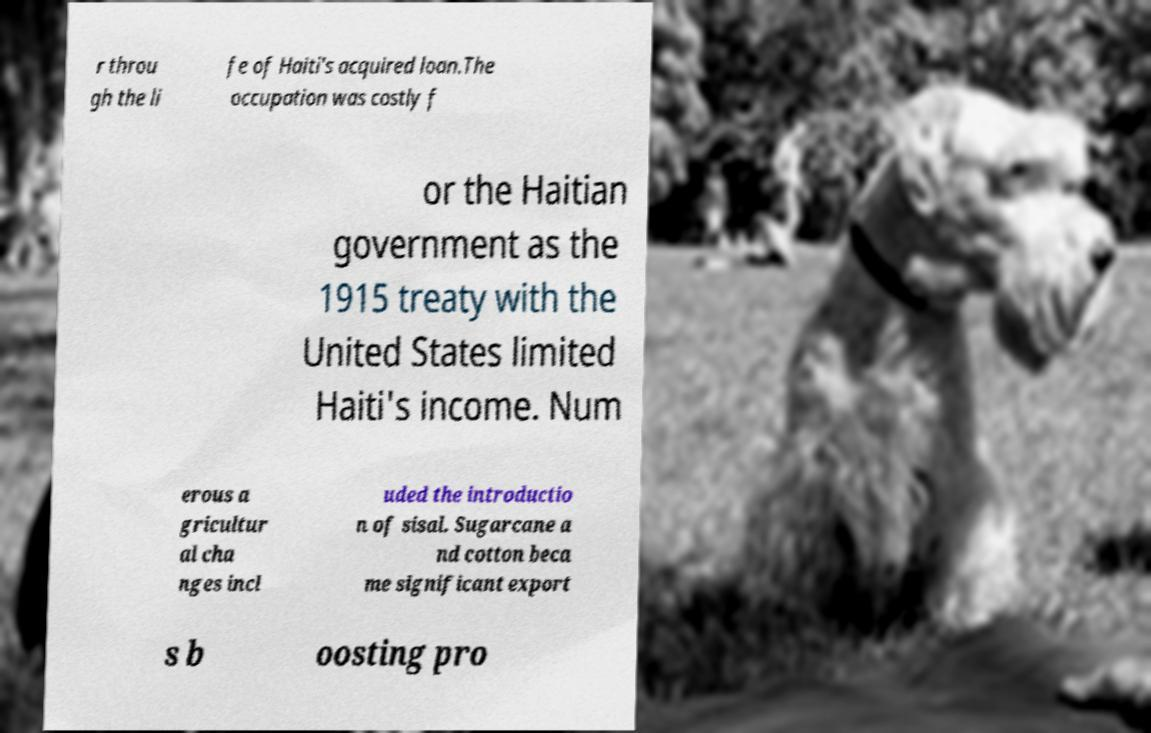What messages or text are displayed in this image? I need them in a readable, typed format. r throu gh the li fe of Haiti's acquired loan.The occupation was costly f or the Haitian government as the 1915 treaty with the United States limited Haiti's income. Num erous a gricultur al cha nges incl uded the introductio n of sisal. Sugarcane a nd cotton beca me significant export s b oosting pro 